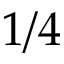Convert formula to latex. <formula><loc_0><loc_0><loc_500><loc_500>1 / 4</formula> 